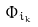<formula> <loc_0><loc_0><loc_500><loc_500>\Phi _ { i _ { k } }</formula> 